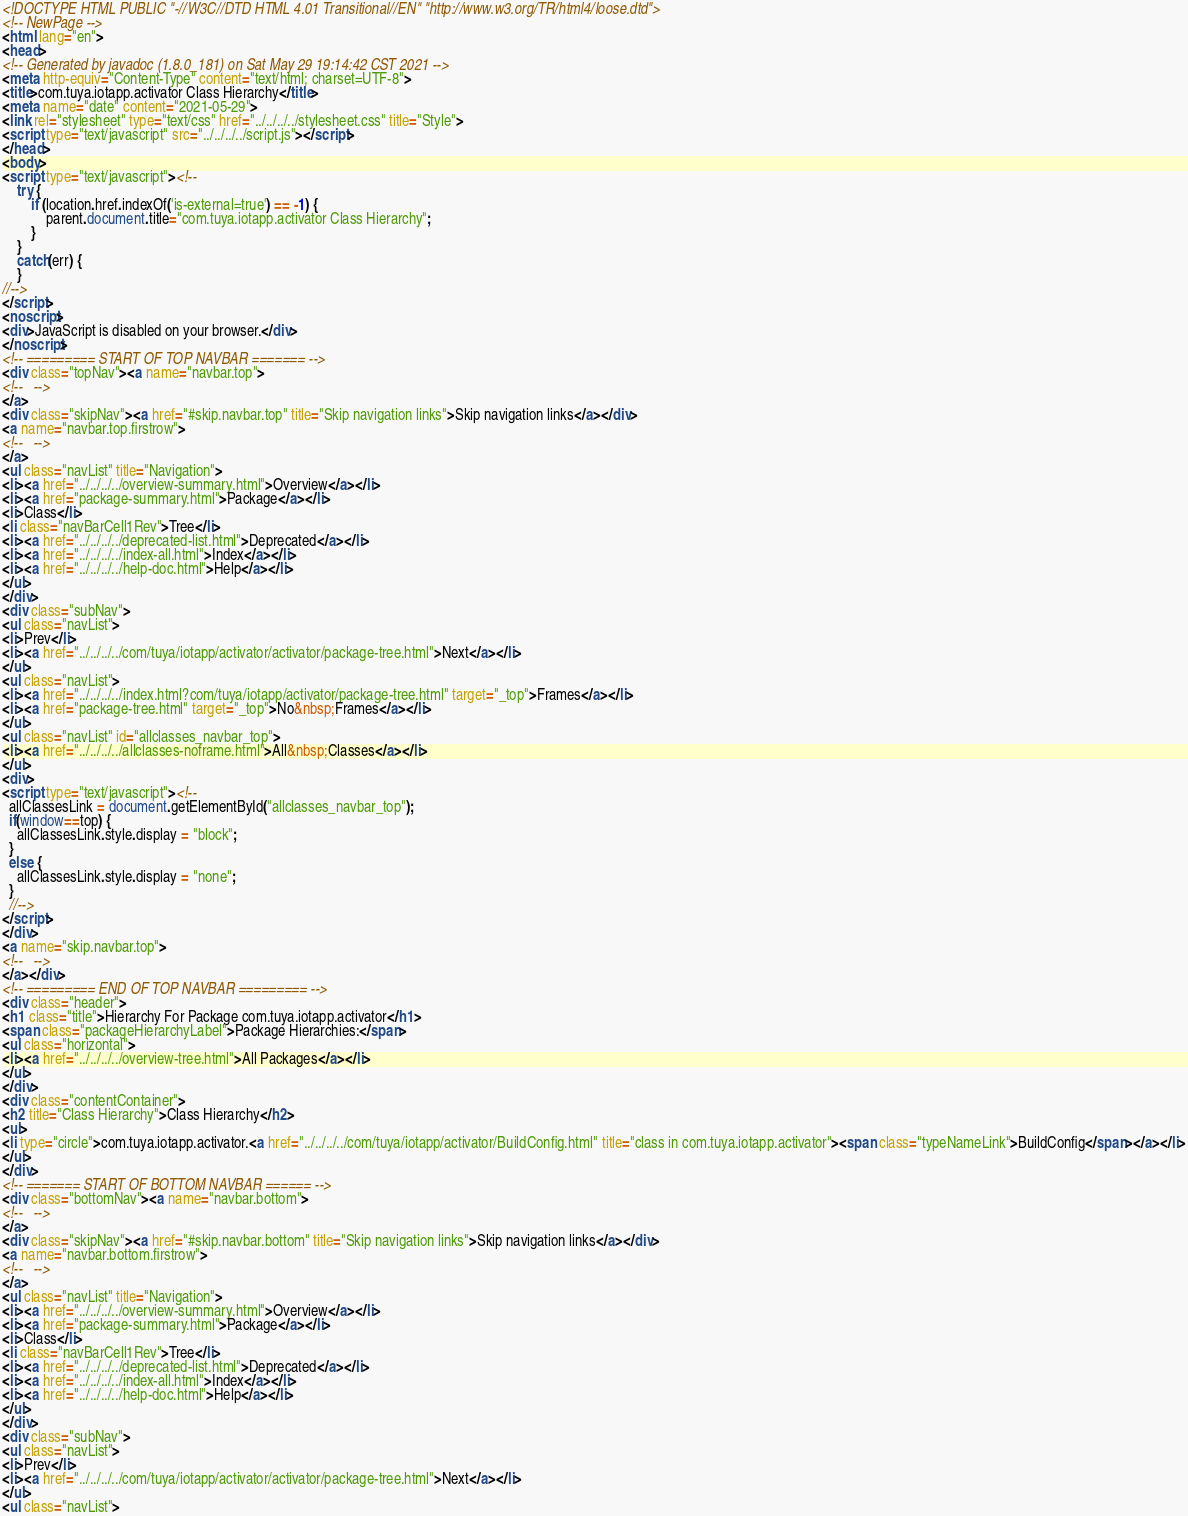Convert code to text. <code><loc_0><loc_0><loc_500><loc_500><_HTML_><!DOCTYPE HTML PUBLIC "-//W3C//DTD HTML 4.01 Transitional//EN" "http://www.w3.org/TR/html4/loose.dtd">
<!-- NewPage -->
<html lang="en">
<head>
<!-- Generated by javadoc (1.8.0_181) on Sat May 29 19:14:42 CST 2021 -->
<meta http-equiv="Content-Type" content="text/html; charset=UTF-8">
<title>com.tuya.iotapp.activator Class Hierarchy</title>
<meta name="date" content="2021-05-29">
<link rel="stylesheet" type="text/css" href="../../../../stylesheet.css" title="Style">
<script type="text/javascript" src="../../../../script.js"></script>
</head>
<body>
<script type="text/javascript"><!--
    try {
        if (location.href.indexOf('is-external=true') == -1) {
            parent.document.title="com.tuya.iotapp.activator Class Hierarchy";
        }
    }
    catch(err) {
    }
//-->
</script>
<noscript>
<div>JavaScript is disabled on your browser.</div>
</noscript>
<!-- ========= START OF TOP NAVBAR ======= -->
<div class="topNav"><a name="navbar.top">
<!--   -->
</a>
<div class="skipNav"><a href="#skip.navbar.top" title="Skip navigation links">Skip navigation links</a></div>
<a name="navbar.top.firstrow">
<!--   -->
</a>
<ul class="navList" title="Navigation">
<li><a href="../../../../overview-summary.html">Overview</a></li>
<li><a href="package-summary.html">Package</a></li>
<li>Class</li>
<li class="navBarCell1Rev">Tree</li>
<li><a href="../../../../deprecated-list.html">Deprecated</a></li>
<li><a href="../../../../index-all.html">Index</a></li>
<li><a href="../../../../help-doc.html">Help</a></li>
</ul>
</div>
<div class="subNav">
<ul class="navList">
<li>Prev</li>
<li><a href="../../../../com/tuya/iotapp/activator/activator/package-tree.html">Next</a></li>
</ul>
<ul class="navList">
<li><a href="../../../../index.html?com/tuya/iotapp/activator/package-tree.html" target="_top">Frames</a></li>
<li><a href="package-tree.html" target="_top">No&nbsp;Frames</a></li>
</ul>
<ul class="navList" id="allclasses_navbar_top">
<li><a href="../../../../allclasses-noframe.html">All&nbsp;Classes</a></li>
</ul>
<div>
<script type="text/javascript"><!--
  allClassesLink = document.getElementById("allclasses_navbar_top");
  if(window==top) {
    allClassesLink.style.display = "block";
  }
  else {
    allClassesLink.style.display = "none";
  }
  //-->
</script>
</div>
<a name="skip.navbar.top">
<!--   -->
</a></div>
<!-- ========= END OF TOP NAVBAR ========= -->
<div class="header">
<h1 class="title">Hierarchy For Package com.tuya.iotapp.activator</h1>
<span class="packageHierarchyLabel">Package Hierarchies:</span>
<ul class="horizontal">
<li><a href="../../../../overview-tree.html">All Packages</a></li>
</ul>
</div>
<div class="contentContainer">
<h2 title="Class Hierarchy">Class Hierarchy</h2>
<ul>
<li type="circle">com.tuya.iotapp.activator.<a href="../../../../com/tuya/iotapp/activator/BuildConfig.html" title="class in com.tuya.iotapp.activator"><span class="typeNameLink">BuildConfig</span></a></li>
</ul>
</div>
<!-- ======= START OF BOTTOM NAVBAR ====== -->
<div class="bottomNav"><a name="navbar.bottom">
<!--   -->
</a>
<div class="skipNav"><a href="#skip.navbar.bottom" title="Skip navigation links">Skip navigation links</a></div>
<a name="navbar.bottom.firstrow">
<!--   -->
</a>
<ul class="navList" title="Navigation">
<li><a href="../../../../overview-summary.html">Overview</a></li>
<li><a href="package-summary.html">Package</a></li>
<li>Class</li>
<li class="navBarCell1Rev">Tree</li>
<li><a href="../../../../deprecated-list.html">Deprecated</a></li>
<li><a href="../../../../index-all.html">Index</a></li>
<li><a href="../../../../help-doc.html">Help</a></li>
</ul>
</div>
<div class="subNav">
<ul class="navList">
<li>Prev</li>
<li><a href="../../../../com/tuya/iotapp/activator/activator/package-tree.html">Next</a></li>
</ul>
<ul class="navList"></code> 